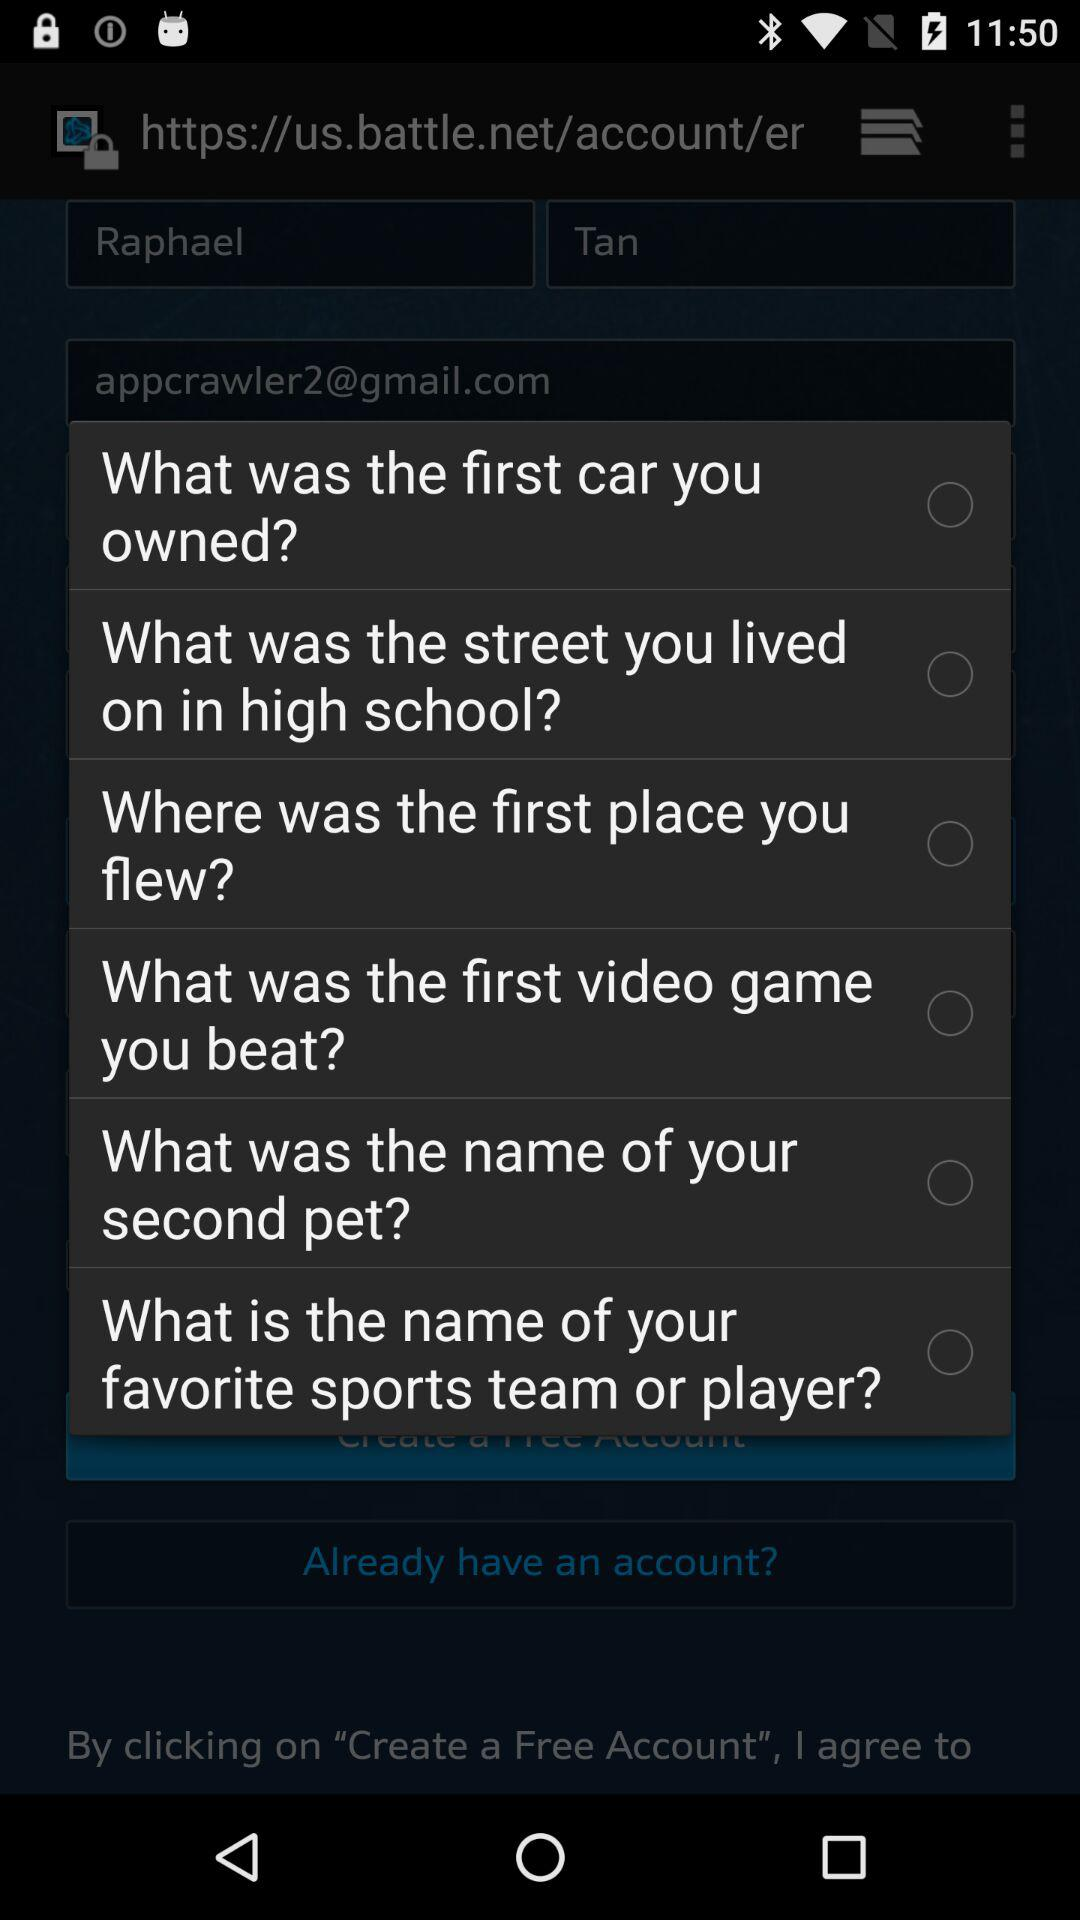Which option is selected?
When the provided information is insufficient, respond with <no answer>. <no answer> 